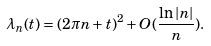Convert formula to latex. <formula><loc_0><loc_0><loc_500><loc_500>\lambda _ { n } ( t ) = ( 2 \pi n + t ) ^ { 2 } + O ( \frac { \ln \left | n \right | } { n } ) .</formula> 